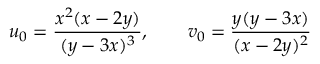<formula> <loc_0><loc_0><loc_500><loc_500>u _ { 0 } = \frac { x ^ { 2 } ( x - 2 y ) } { ( y - 3 x ) ^ { 3 } } , \quad v _ { 0 } = \frac { y ( y - 3 x ) } { ( x - 2 y ) ^ { 2 } }</formula> 